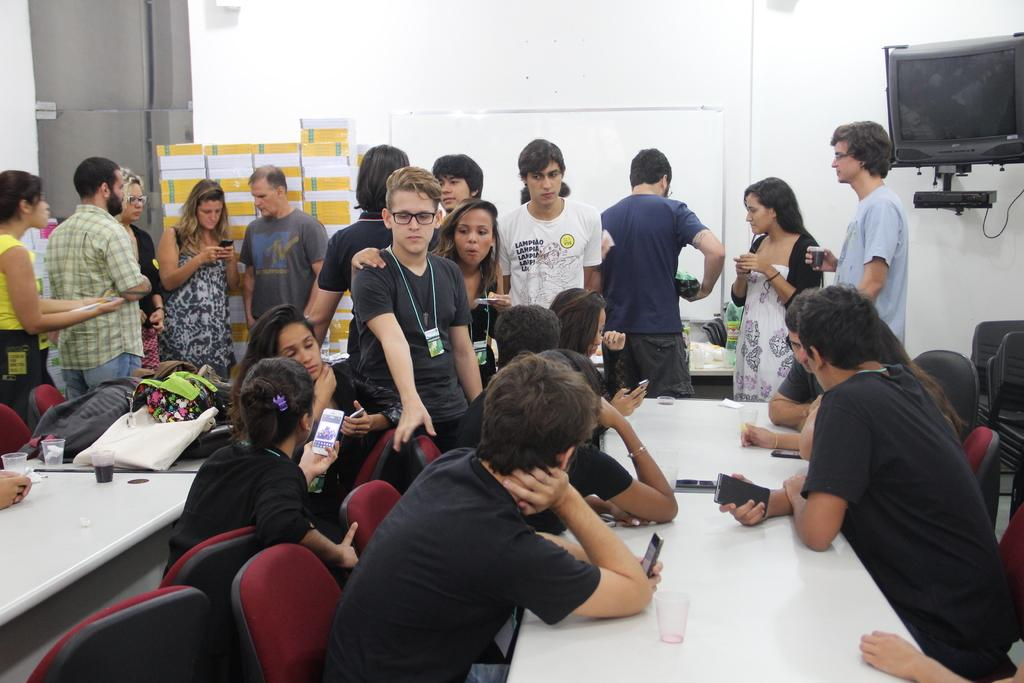What are the people in the image doing? The people on the left side of the image are standing, while others are sitting in chairs. Can you describe the objects on the right side of the image? There is a TV on the right side of the image. What type of insect can be seen crawling on the furniture in the image? There is no insect present in the image, and no furniture is mentioned in the provided facts. 